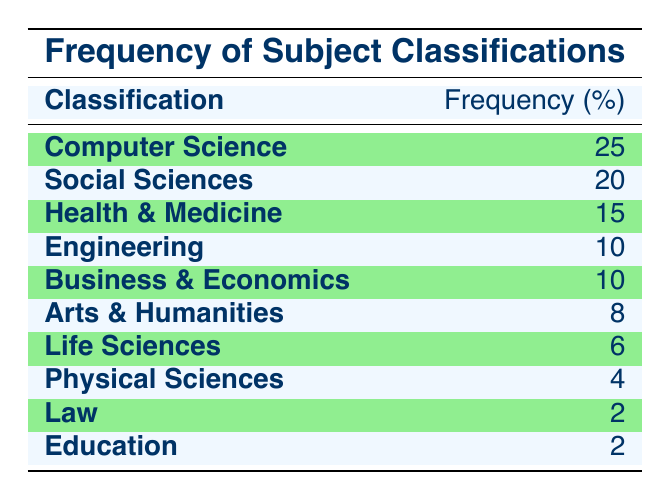What is the highest frequency of subject classifications listed in the table? The highest frequency listed in the table is found in the first row, which corresponds to "Computer Science" with a frequency of 25.
Answer: 25 What classification has the lowest frequency? Looking through the table, "Law" and "Education" both have a frequency of 2, which is the lowest frequency present.
Answer: Law and Education What is the total frequency of the subject classifications? To find the total frequency, we add all the frequencies together: 25 + 20 + 15 + 10 + 10 + 8 + 6 + 4 + 2 + 2 = 102.
Answer: 102 Is "Health & Medicine" listed in the table? Yes, "Health & Medicine" is explicitly mentioned in the table with a frequency of 15.
Answer: Yes What percentage of the total frequency does "Social Sciences" represent? First, identify the frequency of "Social Sciences," which is 20. Then, calculate the percentage by using the formula (20 / 102) * 100, resulting in approximately 19.61%. Thus, rounding gives about 20%.
Answer: 20% How many classifications have a frequency higher than 10? By inspecting the table, we find the classifications with frequencies higher than 10: "Computer Science" (25), "Social Sciences" (20), "Health & Medicine" (15), and "Engineering" (10). The total count is four.
Answer: 4 Which classifications are grouped under the same frequency? There are two classifications with a frequency of 10: "Engineering" and "Business & Economics." Furthermore, there are two classifications with a frequency of 2: "Law" and "Education."
Answer: Engineering, Business & Economics; Law, Education If you exclude "Computer Science," what is the combined frequency of the remaining classifications? Excluding "Computer Science" (25), we sum the frequencies of the other classifications: 20 (Social Sciences) + 15 (Health & Medicine) + 10 (Engineering) + 10 (Business & Economics) + 8 (Arts & Humanities) + 6 (Life Sciences) + 4 (Physical Sciences) + 2 (Law) + 2 (Education) = 77.
Answer: 77 